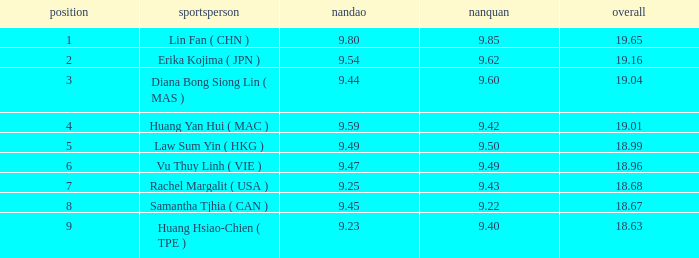Which Nanquan has a Nandao smaller than 9.44, and a Rank smaller than 9, and a Total larger than 18.68? None. 